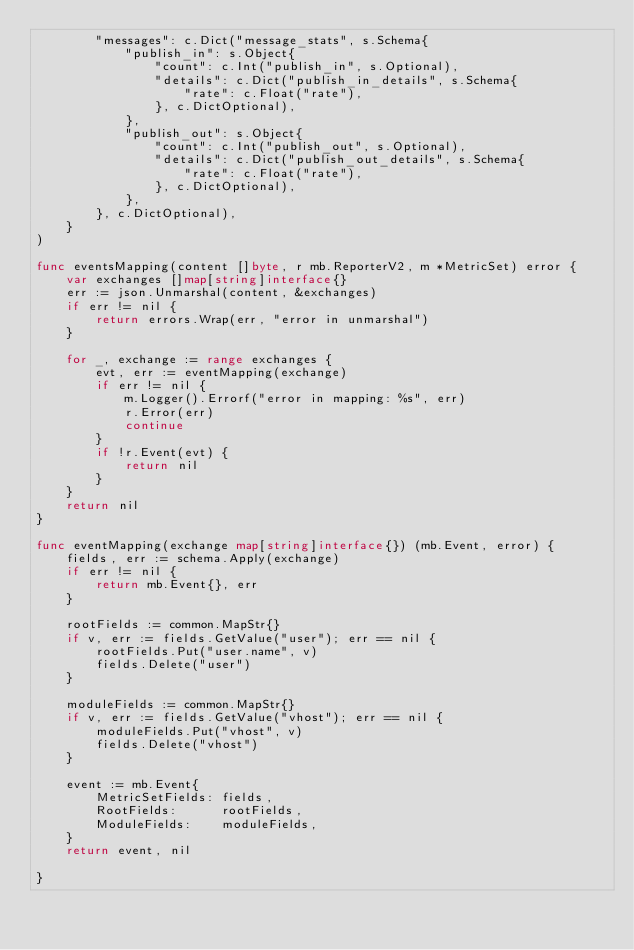Convert code to text. <code><loc_0><loc_0><loc_500><loc_500><_Go_>		"messages": c.Dict("message_stats", s.Schema{
			"publish_in": s.Object{
				"count": c.Int("publish_in", s.Optional),
				"details": c.Dict("publish_in_details", s.Schema{
					"rate": c.Float("rate"),
				}, c.DictOptional),
			},
			"publish_out": s.Object{
				"count": c.Int("publish_out", s.Optional),
				"details": c.Dict("publish_out_details", s.Schema{
					"rate": c.Float("rate"),
				}, c.DictOptional),
			},
		}, c.DictOptional),
	}
)

func eventsMapping(content []byte, r mb.ReporterV2, m *MetricSet) error {
	var exchanges []map[string]interface{}
	err := json.Unmarshal(content, &exchanges)
	if err != nil {
		return errors.Wrap(err, "error in unmarshal")
	}

	for _, exchange := range exchanges {
		evt, err := eventMapping(exchange)
		if err != nil {
			m.Logger().Errorf("error in mapping: %s", err)
			r.Error(err)
			continue
		}
		if !r.Event(evt) {
			return nil
		}
	}
	return nil
}

func eventMapping(exchange map[string]interface{}) (mb.Event, error) {
	fields, err := schema.Apply(exchange)
	if err != nil {
		return mb.Event{}, err
	}

	rootFields := common.MapStr{}
	if v, err := fields.GetValue("user"); err == nil {
		rootFields.Put("user.name", v)
		fields.Delete("user")
	}

	moduleFields := common.MapStr{}
	if v, err := fields.GetValue("vhost"); err == nil {
		moduleFields.Put("vhost", v)
		fields.Delete("vhost")
	}

	event := mb.Event{
		MetricSetFields: fields,
		RootFields:      rootFields,
		ModuleFields:    moduleFields,
	}
	return event, nil

}
</code> 